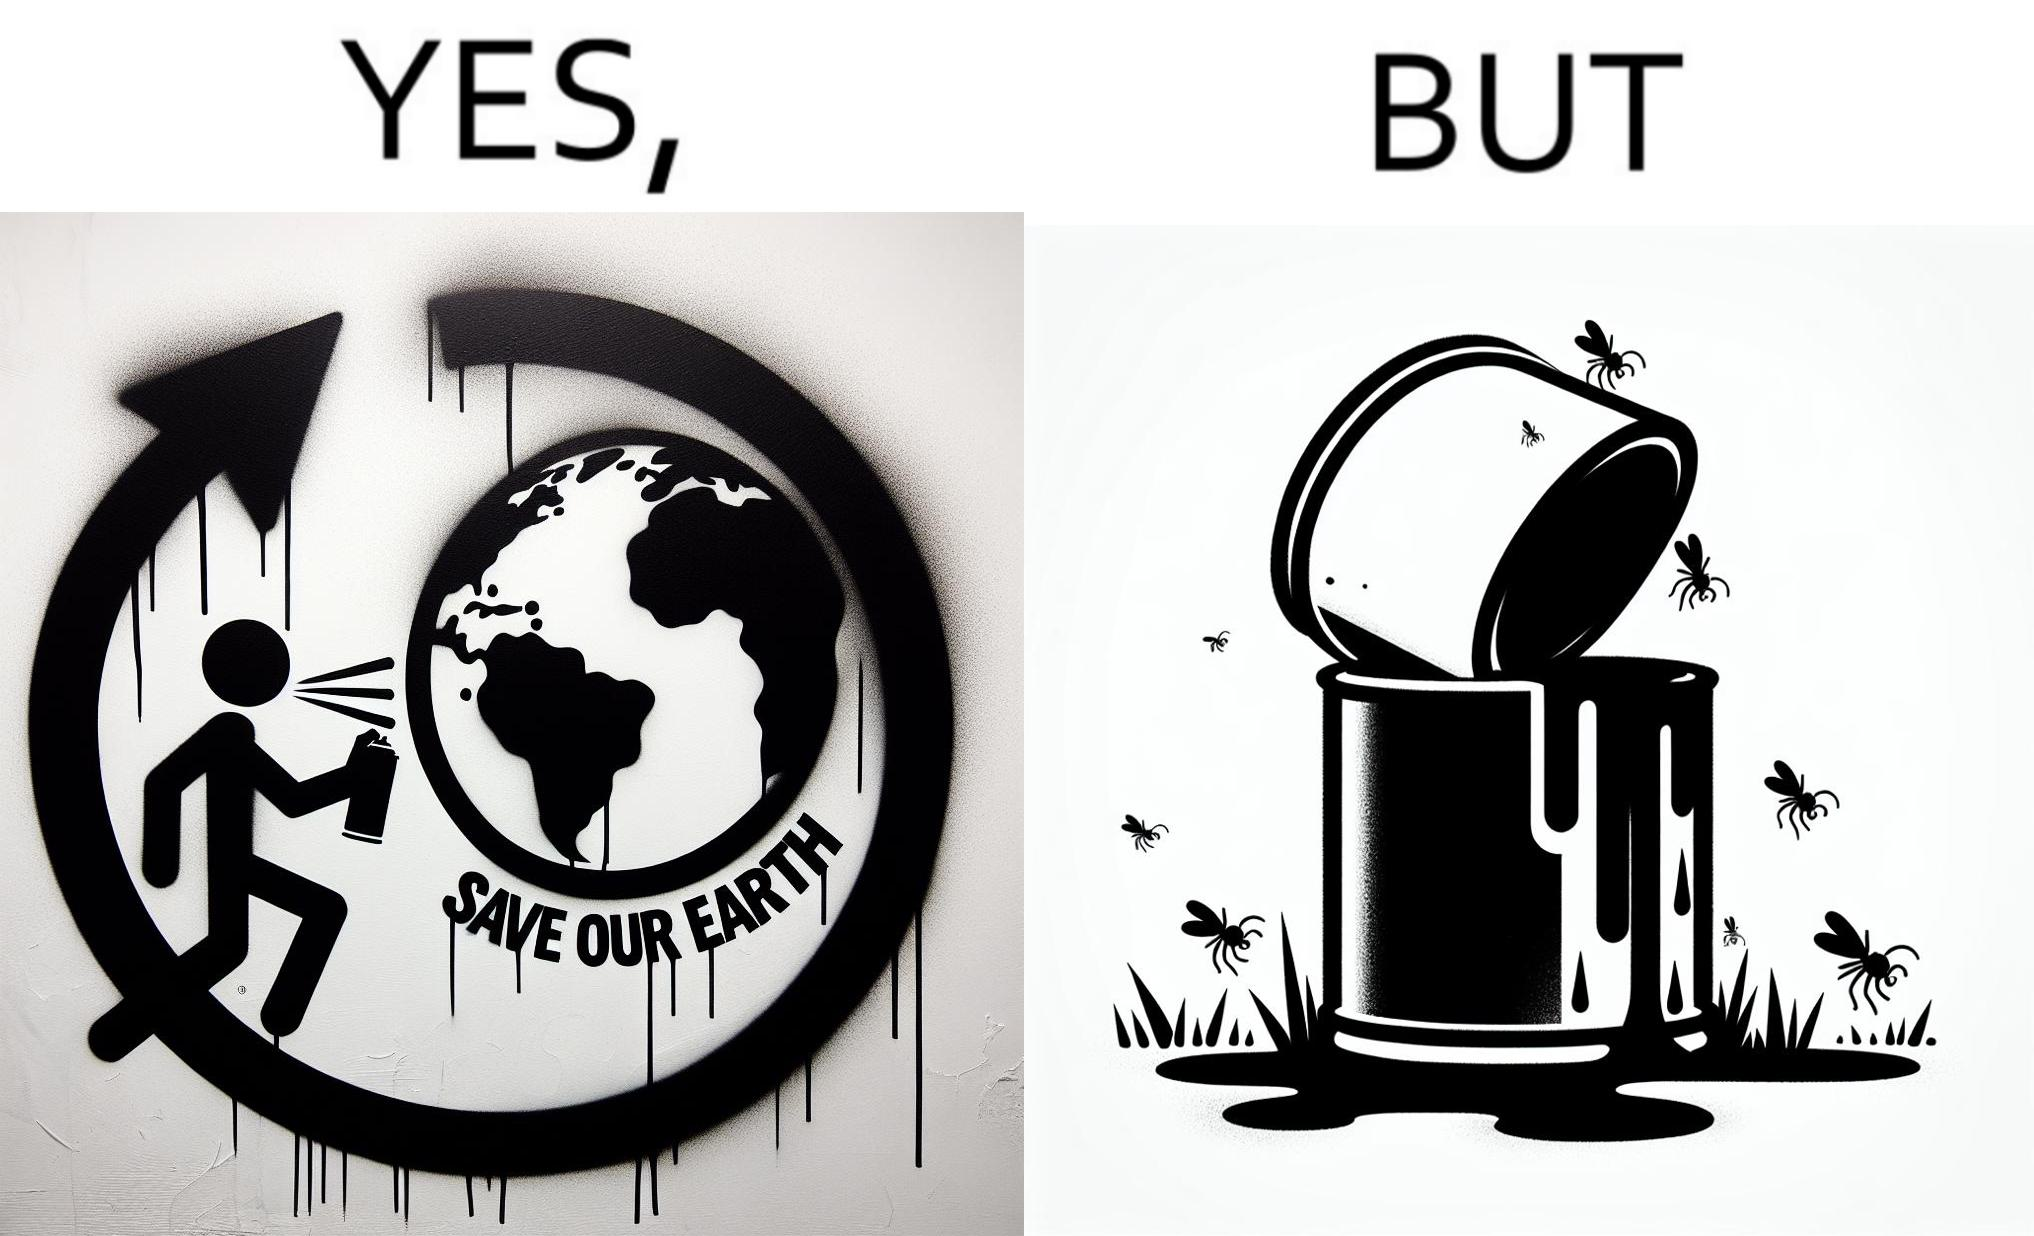What is shown in the left half versus the right half of this image? In the left part of the image: A man drawing a graffiti themed "save Our earth". In the right part of the image: A can of paint, overflowing onto the grass. The paint seems to be harmful for insects. 